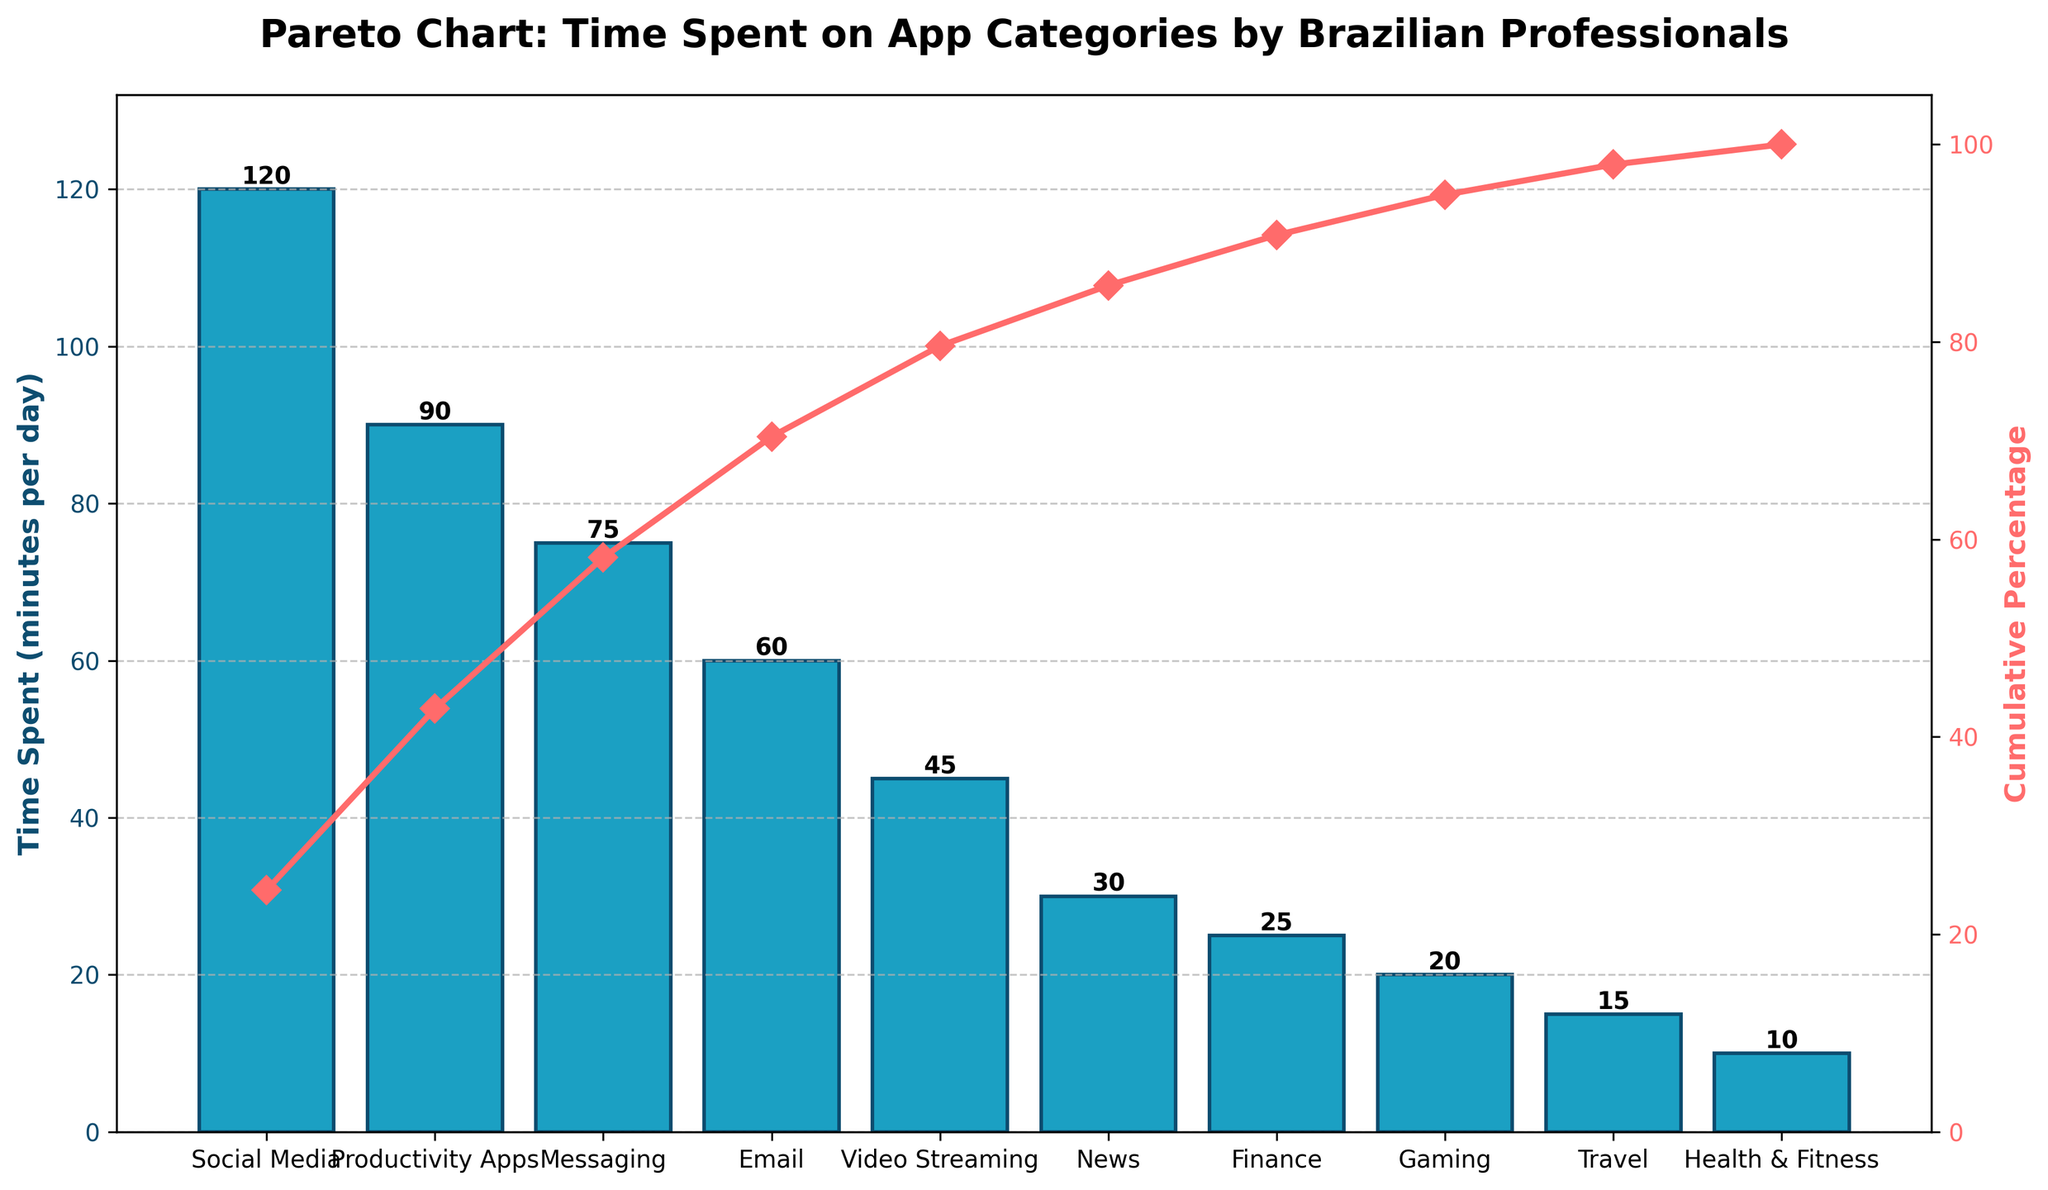What is the title of the figure? The title is typically located at the top of the figure. For this figure, it states the overall theme and focus.
Answer: Pareto Chart: Time Spent on App Categories by Brazilian Professionals Which app category has the highest time spent per day? The bar that reaches the highest value on the primary y-axis represents the app category with the most time spent per day.
Answer: Social Media What is the cumulative percentage for the first three app categories? Add the cumulative percentages of the first three categories: Social Media, Productivity Apps, and Messaging.
Answer: 63.6% What is the difference in time spent between Video Streaming and Email? Subtract the time spent on Video Streaming from the time spent on Email.
Answer: 15 minutes How many categories have a time spent of 30 minutes per day or more? Count the categories on the x-axis that have bars reaching 30 minutes or more on the primary y-axis.
Answer: 5 Which category is the least time-consuming? Find the category with the shortest bar on the primary y-axis.
Answer: Health & Fitness What cumulative percentage does the News category have? Look for the cumulative percentage value corresponding to the News category on the secondary y-axis.
Answer: 91.7% By looking at the cumulative percentage line, what percentage threshold includes the highest number of app categories? Identify the percentage threshold on the secondary y-axis that intersects with the most vertical categories.
Answer: 100% Between Productivity Apps and Messaging, which category has more time spent, and by how much? Compare the heights of the bars for Productivity Apps and Messaging, and calculate the difference.
Answer: Productivity Apps by 15 minutes What is the total amount of time spent on all categories combined? Sum the time spent for all categories as shown along the x-axis.
Answer: 490 minutes 